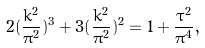Convert formula to latex. <formula><loc_0><loc_0><loc_500><loc_500>2 ( \frac { k ^ { 2 } } { \pi ^ { 2 } } ) ^ { 3 } + 3 ( \frac { k ^ { 2 } } { \pi ^ { 2 } } ) ^ { 2 } = 1 + \frac { \tau ^ { 2 } } { \pi ^ { 4 } } ,</formula> 